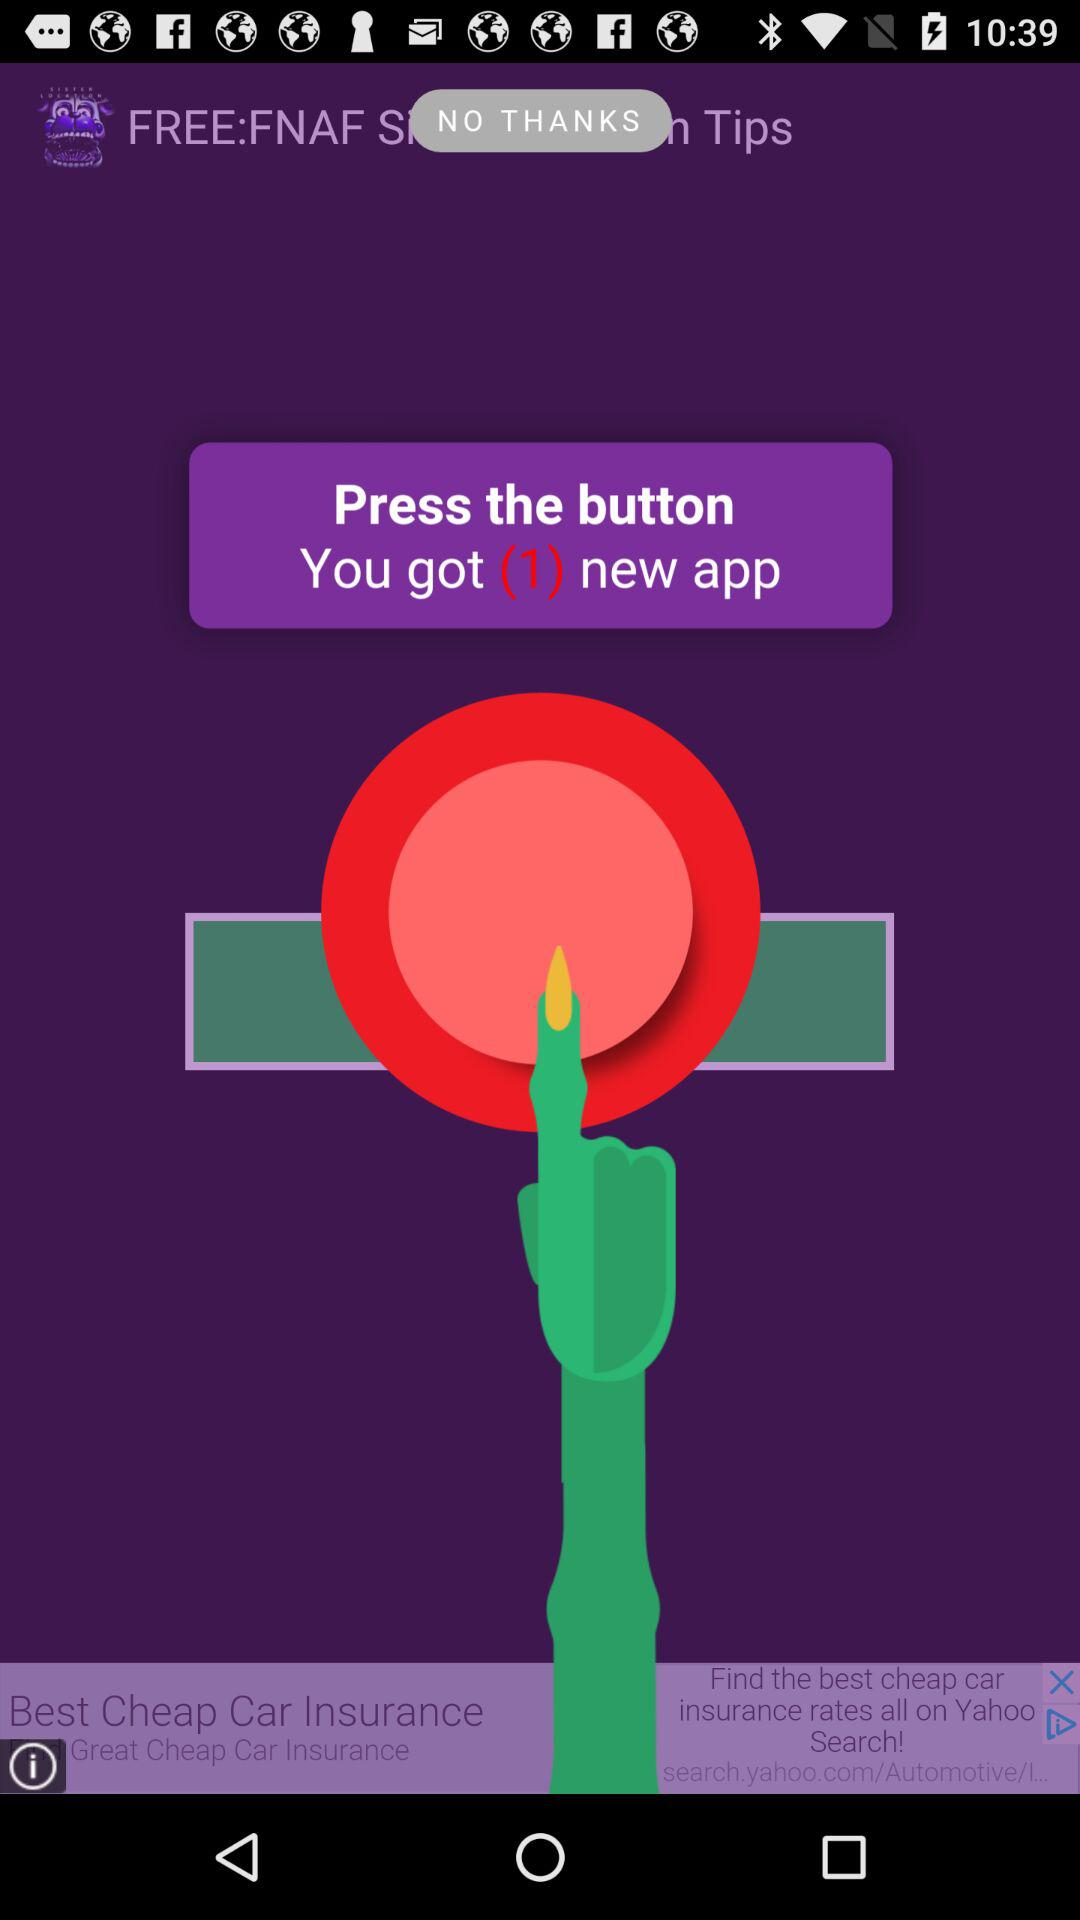How to get the new application? To get the new application, press the button. 